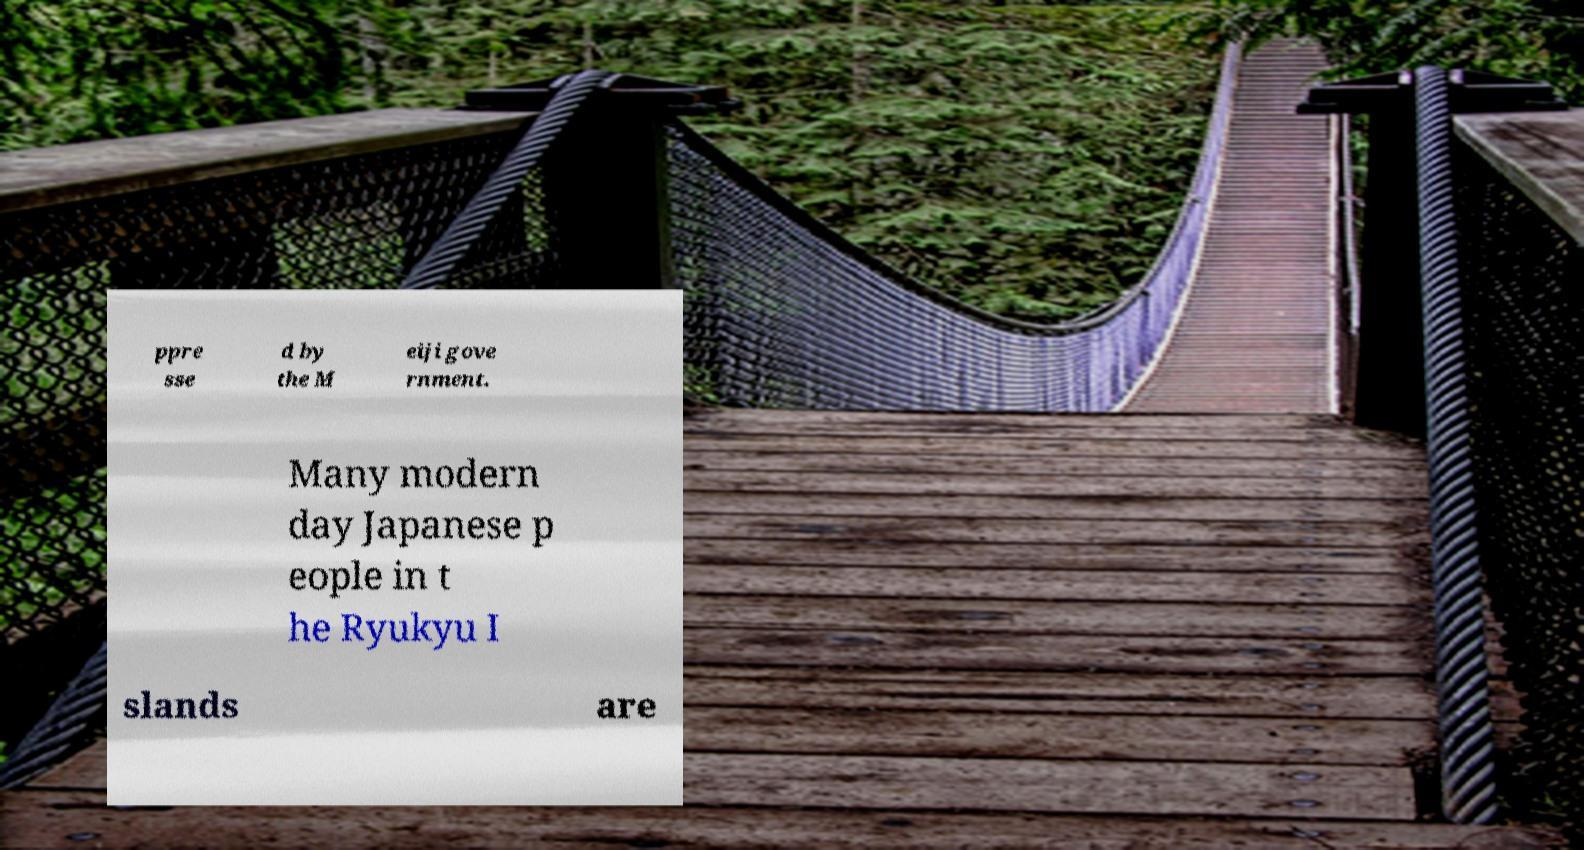What messages or text are displayed in this image? I need them in a readable, typed format. ppre sse d by the M eiji gove rnment. Many modern day Japanese p eople in t he Ryukyu I slands are 